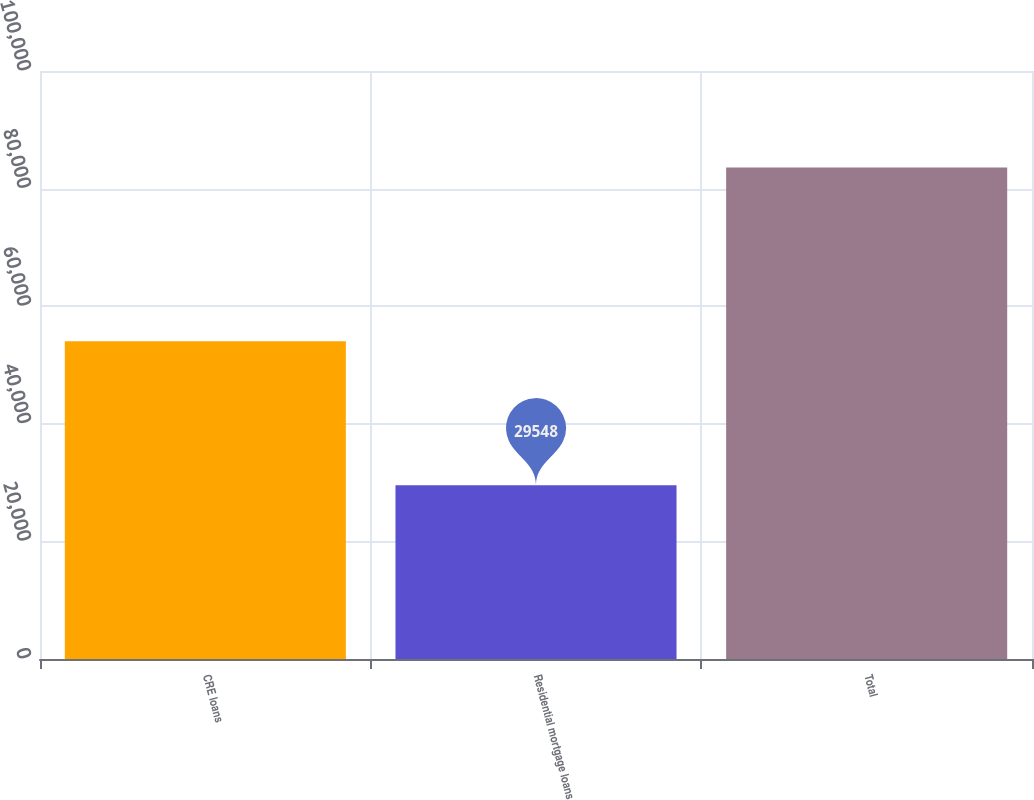<chart> <loc_0><loc_0><loc_500><loc_500><bar_chart><fcel>CRE loans<fcel>Residential mortgage loans<fcel>Total<nl><fcel>54053<fcel>29548<fcel>83601<nl></chart> 